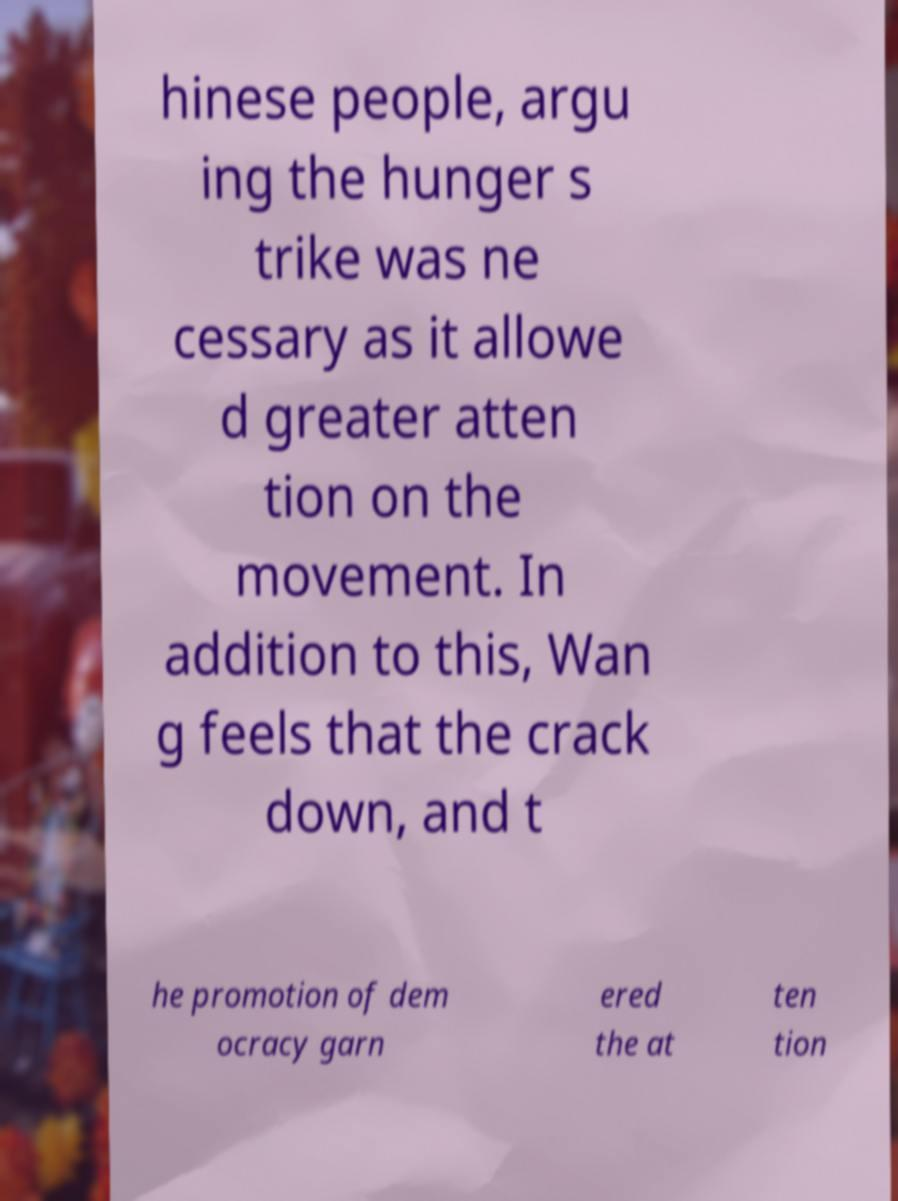Can you read and provide the text displayed in the image?This photo seems to have some interesting text. Can you extract and type it out for me? hinese people, argu ing the hunger s trike was ne cessary as it allowe d greater atten tion on the movement. In addition to this, Wan g feels that the crack down, and t he promotion of dem ocracy garn ered the at ten tion 